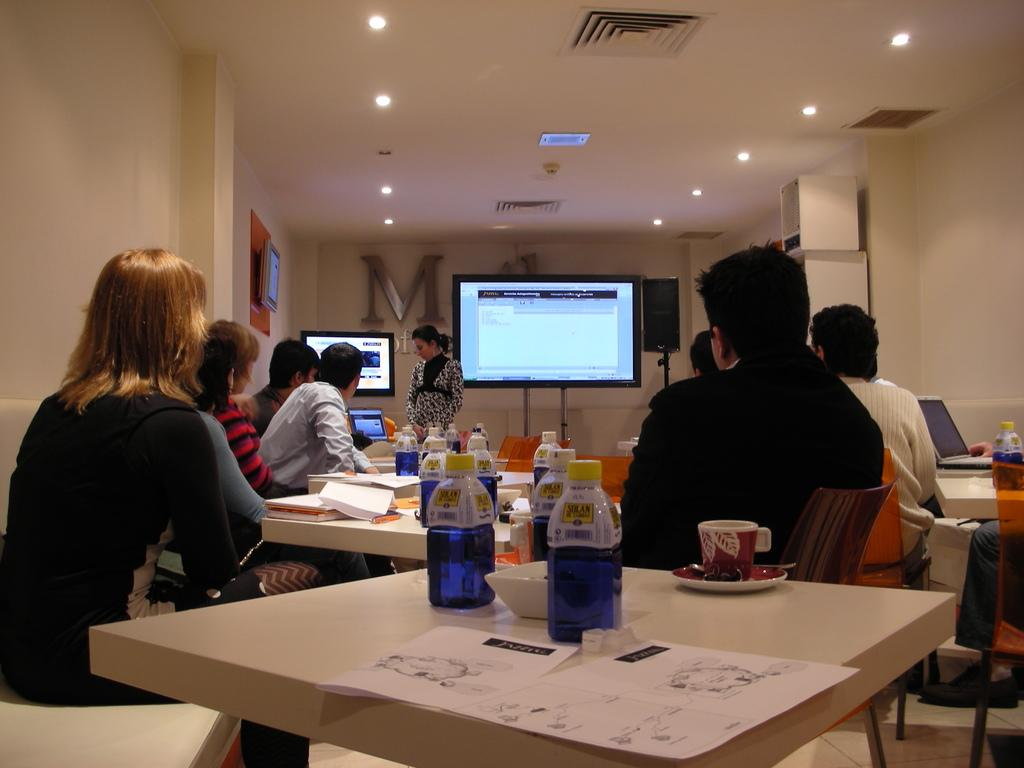What are the people in the image doing? People are sitting on chairs in the image. What is on the table in the image? There is a bottle, a cap, a saucier, and a paper on the table in the image. What is the purpose of the cap on the table? The cap is likely meant to be used with the bottle, possibly as a lid or cover. What is the saucier used for? The saucier is a type of cooking pot, typically used for making sauces or other liquid-based dishes. What is the television used for? The television is likely used for entertainment or information purposes, such as watching shows or news. What is the purpose of the lights in the roof? The lights in the roof provide illumination for the room, making it easier to see and navigate. How does the feeling of rest affect the authority in the image? There is no mention of feelings or authority in the image, as it primarily focuses on people sitting, a table with various items, a television, and lights in the roof. 